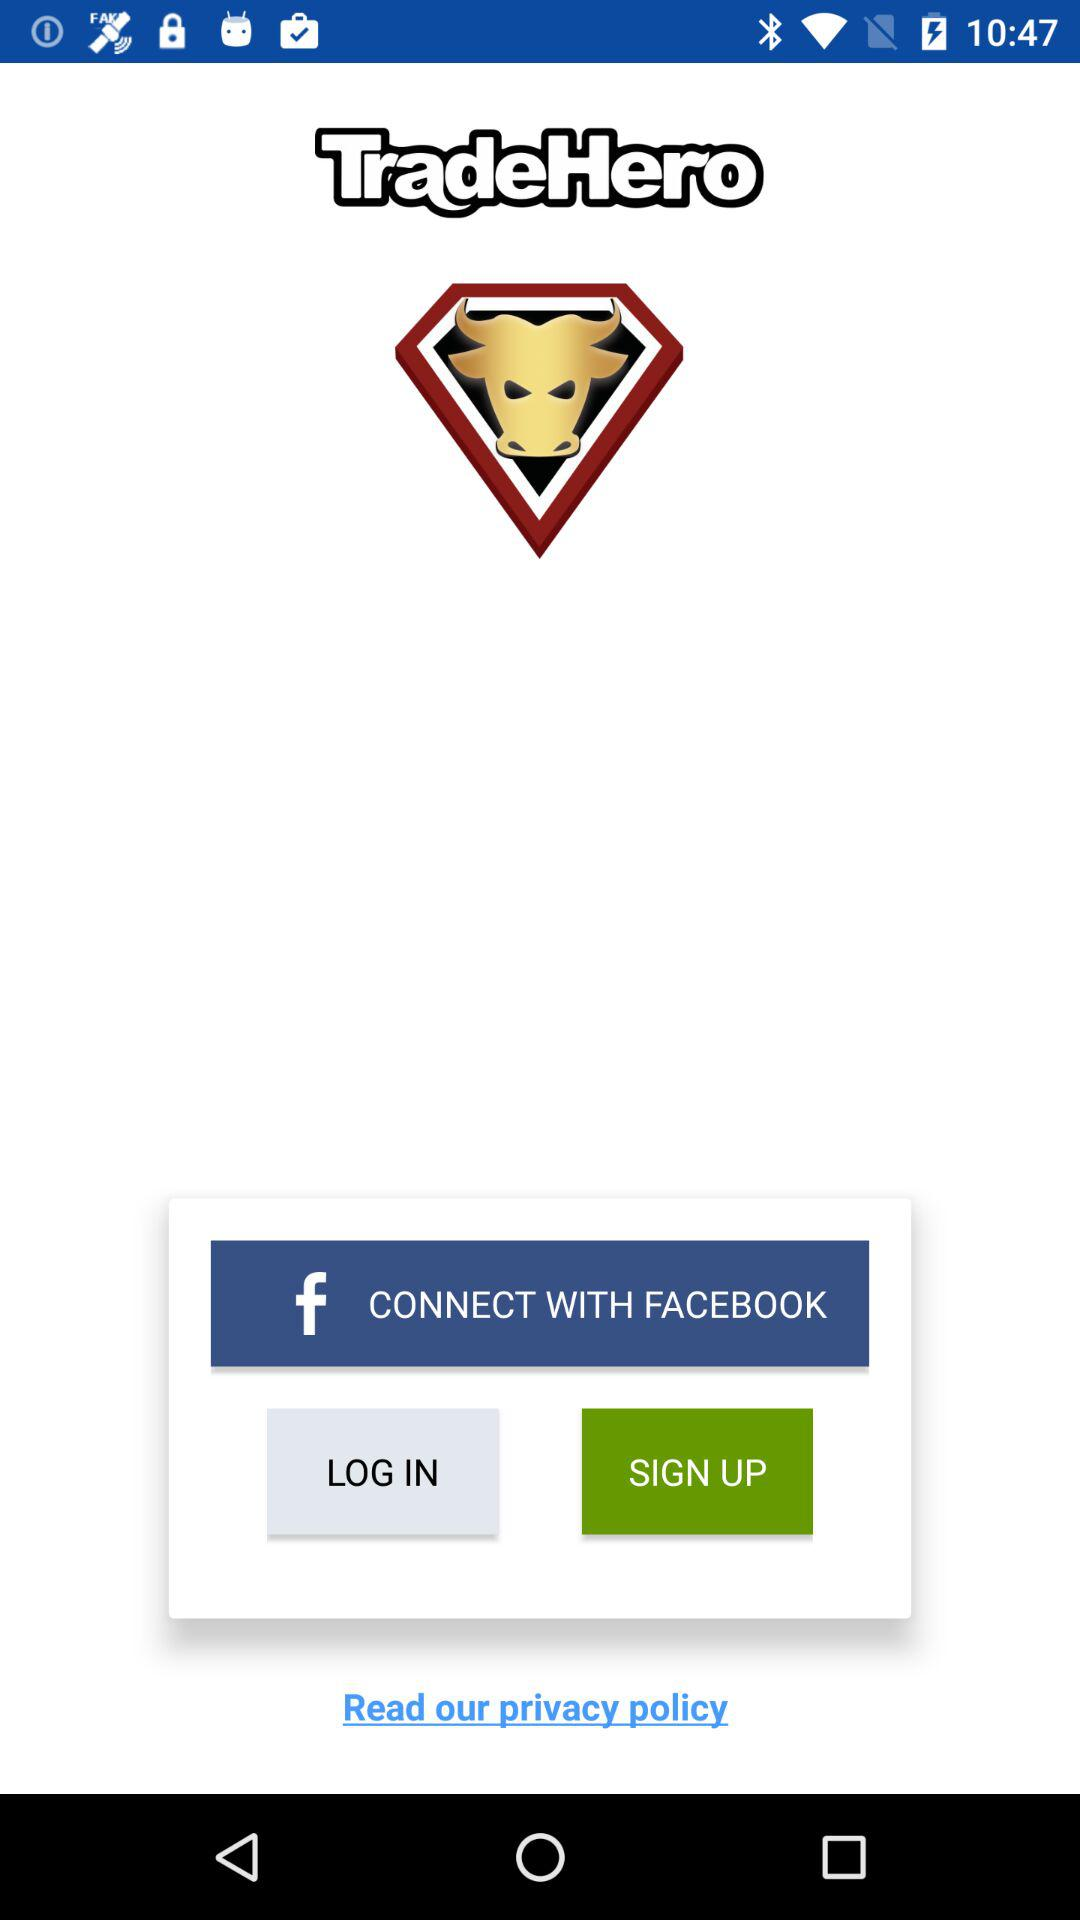What is the name of the application? The name of the application is "TradeHero". 